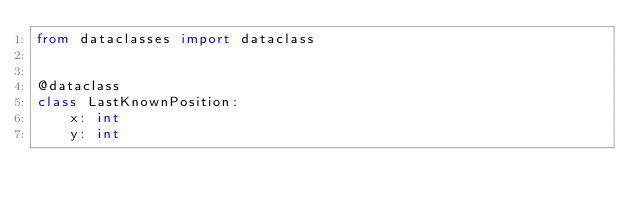<code> <loc_0><loc_0><loc_500><loc_500><_Python_>from dataclasses import dataclass


@dataclass
class LastKnownPosition:
    x: int
    y: int

</code> 